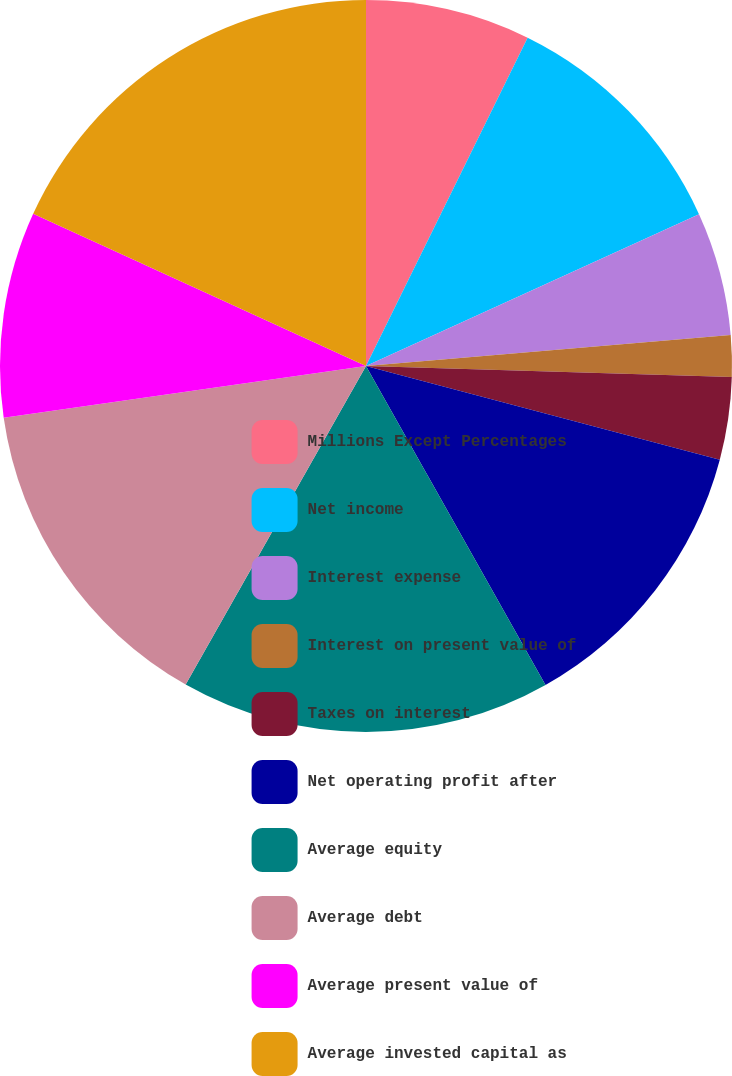<chart> <loc_0><loc_0><loc_500><loc_500><pie_chart><fcel>Millions Except Percentages<fcel>Net income<fcel>Interest expense<fcel>Interest on present value of<fcel>Taxes on interest<fcel>Net operating profit after<fcel>Average equity<fcel>Average debt<fcel>Average present value of<fcel>Average invested capital as<nl><fcel>7.28%<fcel>10.91%<fcel>5.46%<fcel>1.83%<fcel>3.64%<fcel>12.72%<fcel>16.36%<fcel>14.54%<fcel>9.09%<fcel>18.17%<nl></chart> 